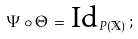Convert formula to latex. <formula><loc_0><loc_0><loc_500><loc_500>\Psi \circ \Theta \, = \, \text {Id} _ { P ( { \mathbb { X } } ) } \, ;</formula> 